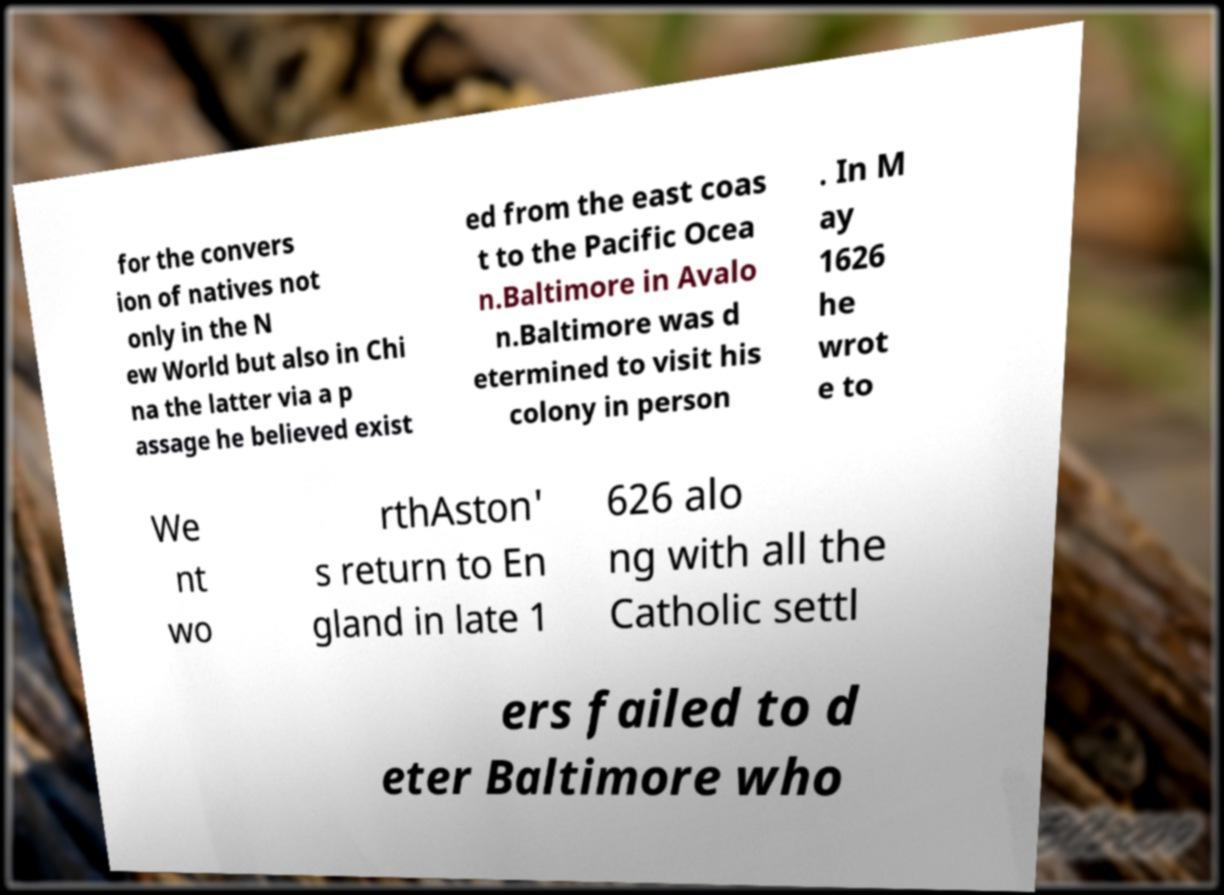For documentation purposes, I need the text within this image transcribed. Could you provide that? for the convers ion of natives not only in the N ew World but also in Chi na the latter via a p assage he believed exist ed from the east coas t to the Pacific Ocea n.Baltimore in Avalo n.Baltimore was d etermined to visit his colony in person . In M ay 1626 he wrot e to We nt wo rthAston' s return to En gland in late 1 626 alo ng with all the Catholic settl ers failed to d eter Baltimore who 